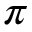<formula> <loc_0><loc_0><loc_500><loc_500>\pi</formula> 